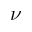<formula> <loc_0><loc_0><loc_500><loc_500>\nu</formula> 